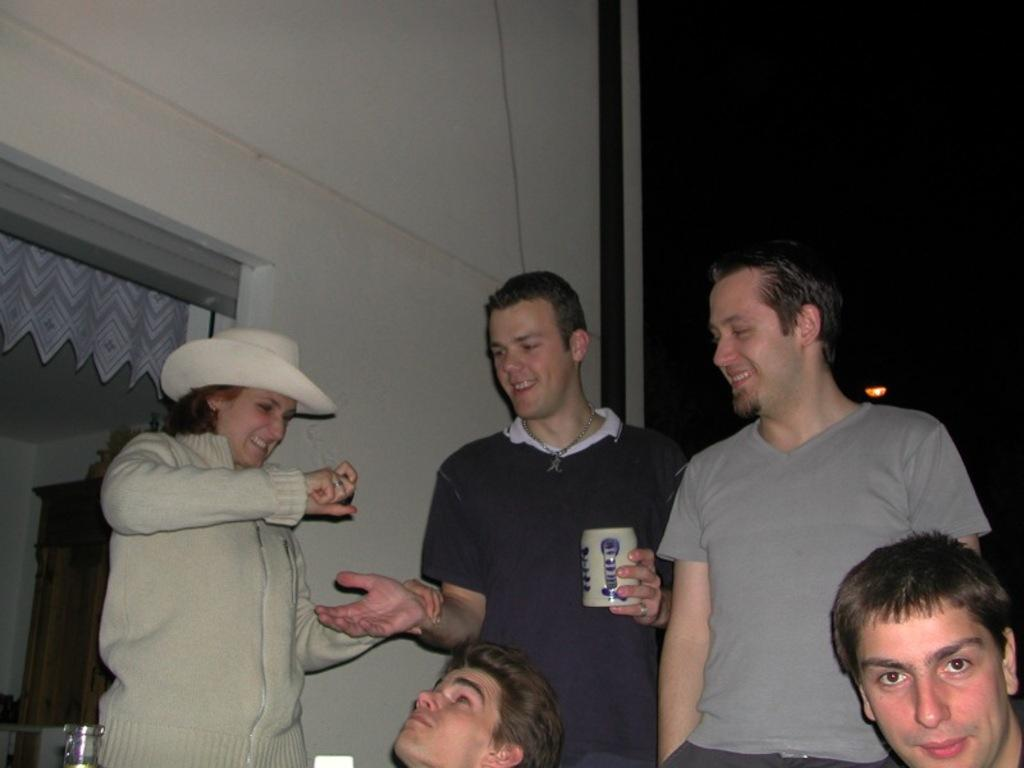How many people are present in the image? There are five persons in the image. What are the positions of three of the persons? Three of the persons are standing. What can be seen in the background of the image? There is a wall in the background of the image, and there are other items visible as well. What type of straw is being used by the person in the image? There is no straw present in the image. How many gloves can be seen on the hands of the persons in the image? There are no gloves visible on the hands of the persons in the image. 